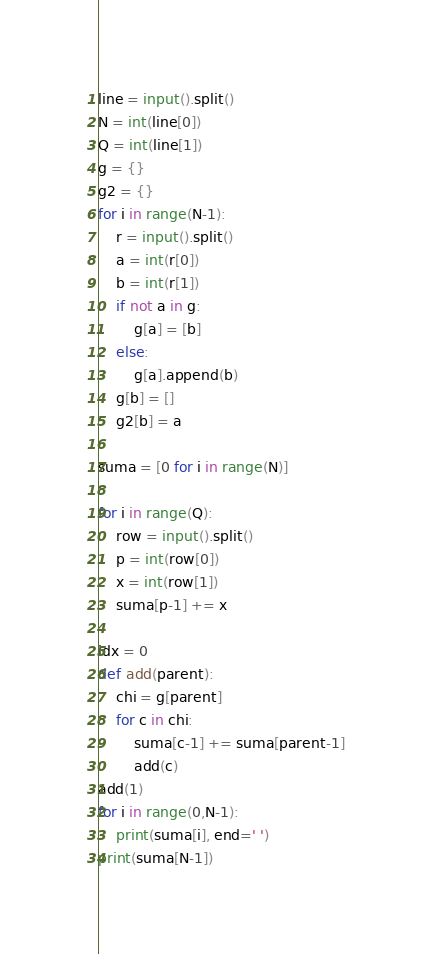Convert code to text. <code><loc_0><loc_0><loc_500><loc_500><_Python_>line = input().split()
N = int(line[0])
Q = int(line[1])
g = {}
g2 = {}
for i in range(N-1):
    r = input().split()
    a = int(r[0])
    b = int(r[1])
    if not a in g:
        g[a] = [b]
    else:
        g[a].append(b)
    g[b] = []
    g2[b] = a

suma = [0 for i in range(N)]

for i in range(Q):
    row = input().split()
    p = int(row[0])
    x = int(row[1])
    suma[p-1] += x

idx = 0
def add(parent):
    chi = g[parent]
    for c in chi:
        suma[c-1] += suma[parent-1] 
        add(c)
add(1)
for i in range(0,N-1):
    print(suma[i], end=' ')
print(suma[N-1])</code> 